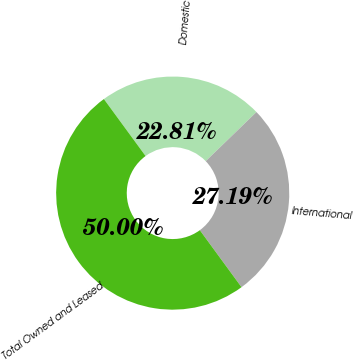Convert chart to OTSL. <chart><loc_0><loc_0><loc_500><loc_500><pie_chart><fcel>Domestic<fcel>International<fcel>Total Owned and Leased<nl><fcel>22.81%<fcel>27.19%<fcel>50.0%<nl></chart> 